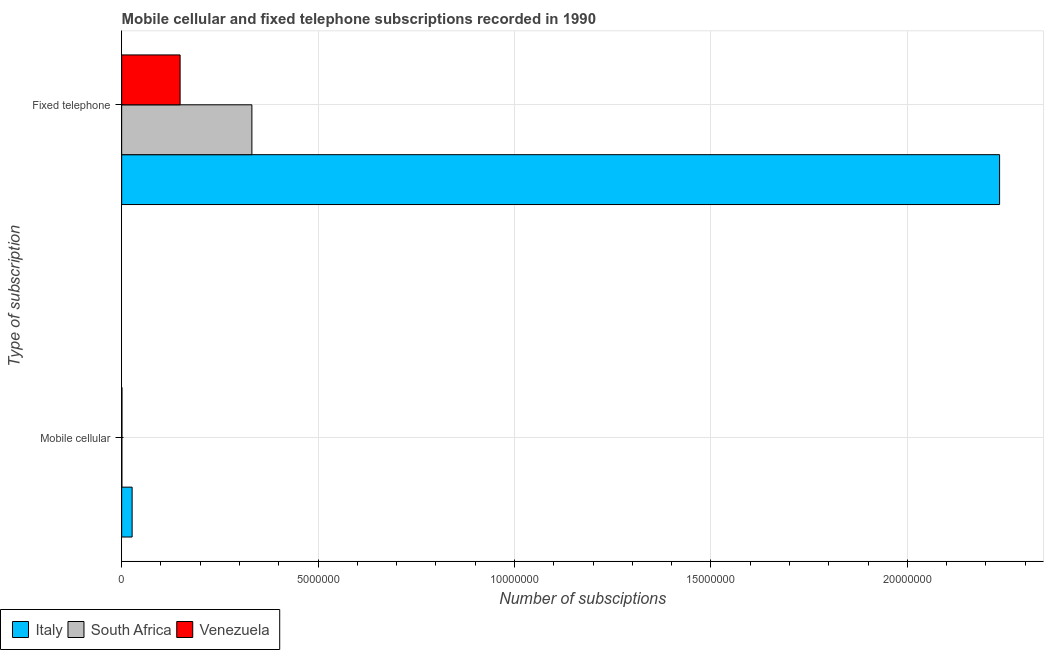How many groups of bars are there?
Your answer should be compact. 2. How many bars are there on the 2nd tick from the top?
Provide a short and direct response. 3. How many bars are there on the 1st tick from the bottom?
Your response must be concise. 3. What is the label of the 1st group of bars from the top?
Offer a terse response. Fixed telephone. What is the number of fixed telephone subscriptions in South Africa?
Provide a succinct answer. 3.32e+06. Across all countries, what is the maximum number of mobile cellular subscriptions?
Provide a short and direct response. 2.66e+05. Across all countries, what is the minimum number of fixed telephone subscriptions?
Offer a very short reply. 1.49e+06. In which country was the number of fixed telephone subscriptions maximum?
Your answer should be very brief. Italy. In which country was the number of fixed telephone subscriptions minimum?
Offer a terse response. Venezuela. What is the total number of mobile cellular subscriptions in the graph?
Offer a terse response. 2.79e+05. What is the difference between the number of fixed telephone subscriptions in South Africa and that in Venezuela?
Your answer should be compact. 1.83e+06. What is the difference between the number of fixed telephone subscriptions in Italy and the number of mobile cellular subscriptions in South Africa?
Your answer should be very brief. 2.23e+07. What is the average number of mobile cellular subscriptions per country?
Provide a succinct answer. 9.30e+04. What is the difference between the number of fixed telephone subscriptions and number of mobile cellular subscriptions in Italy?
Offer a terse response. 2.21e+07. What is the ratio of the number of fixed telephone subscriptions in Venezuela to that in South Africa?
Your answer should be compact. 0.45. Is the number of fixed telephone subscriptions in Venezuela less than that in South Africa?
Keep it short and to the point. Yes. In how many countries, is the number of mobile cellular subscriptions greater than the average number of mobile cellular subscriptions taken over all countries?
Your answer should be compact. 1. What does the 2nd bar from the top in Fixed telephone represents?
Give a very brief answer. South Africa. What does the 3rd bar from the bottom in Fixed telephone represents?
Keep it short and to the point. Venezuela. How many countries are there in the graph?
Provide a short and direct response. 3. What is the difference between two consecutive major ticks on the X-axis?
Provide a succinct answer. 5.00e+06. Does the graph contain any zero values?
Your answer should be compact. No. Does the graph contain grids?
Offer a terse response. Yes. Where does the legend appear in the graph?
Your answer should be very brief. Bottom left. How are the legend labels stacked?
Your response must be concise. Horizontal. What is the title of the graph?
Your response must be concise. Mobile cellular and fixed telephone subscriptions recorded in 1990. Does "Tajikistan" appear as one of the legend labels in the graph?
Ensure brevity in your answer.  No. What is the label or title of the X-axis?
Your response must be concise. Number of subsciptions. What is the label or title of the Y-axis?
Provide a short and direct response. Type of subscription. What is the Number of subsciptions in Italy in Mobile cellular?
Make the answer very short. 2.66e+05. What is the Number of subsciptions of South Africa in Mobile cellular?
Your answer should be compact. 5680. What is the Number of subsciptions in Venezuela in Mobile cellular?
Your response must be concise. 7422. What is the Number of subsciptions of Italy in Fixed telephone?
Your response must be concise. 2.24e+07. What is the Number of subsciptions of South Africa in Fixed telephone?
Ensure brevity in your answer.  3.32e+06. What is the Number of subsciptions of Venezuela in Fixed telephone?
Offer a terse response. 1.49e+06. Across all Type of subscription, what is the maximum Number of subsciptions of Italy?
Provide a short and direct response. 2.24e+07. Across all Type of subscription, what is the maximum Number of subsciptions of South Africa?
Provide a short and direct response. 3.32e+06. Across all Type of subscription, what is the maximum Number of subsciptions of Venezuela?
Offer a very short reply. 1.49e+06. Across all Type of subscription, what is the minimum Number of subsciptions in Italy?
Offer a very short reply. 2.66e+05. Across all Type of subscription, what is the minimum Number of subsciptions in South Africa?
Offer a terse response. 5680. Across all Type of subscription, what is the minimum Number of subsciptions in Venezuela?
Your answer should be compact. 7422. What is the total Number of subsciptions of Italy in the graph?
Keep it short and to the point. 2.26e+07. What is the total Number of subsciptions of South Africa in the graph?
Your response must be concise. 3.32e+06. What is the total Number of subsciptions in Venezuela in the graph?
Provide a short and direct response. 1.50e+06. What is the difference between the Number of subsciptions in Italy in Mobile cellular and that in Fixed telephone?
Your answer should be compact. -2.21e+07. What is the difference between the Number of subsciptions in South Africa in Mobile cellular and that in Fixed telephone?
Offer a very short reply. -3.31e+06. What is the difference between the Number of subsciptions in Venezuela in Mobile cellular and that in Fixed telephone?
Make the answer very short. -1.48e+06. What is the difference between the Number of subsciptions in Italy in Mobile cellular and the Number of subsciptions in South Africa in Fixed telephone?
Offer a very short reply. -3.05e+06. What is the difference between the Number of subsciptions in Italy in Mobile cellular and the Number of subsciptions in Venezuela in Fixed telephone?
Offer a terse response. -1.22e+06. What is the difference between the Number of subsciptions of South Africa in Mobile cellular and the Number of subsciptions of Venezuela in Fixed telephone?
Keep it short and to the point. -1.48e+06. What is the average Number of subsciptions of Italy per Type of subscription?
Offer a terse response. 1.13e+07. What is the average Number of subsciptions in South Africa per Type of subscription?
Make the answer very short. 1.66e+06. What is the average Number of subsciptions in Venezuela per Type of subscription?
Provide a short and direct response. 7.48e+05. What is the difference between the Number of subsciptions of Italy and Number of subsciptions of South Africa in Mobile cellular?
Provide a succinct answer. 2.60e+05. What is the difference between the Number of subsciptions in Italy and Number of subsciptions in Venezuela in Mobile cellular?
Your answer should be compact. 2.59e+05. What is the difference between the Number of subsciptions of South Africa and Number of subsciptions of Venezuela in Mobile cellular?
Your answer should be compact. -1742. What is the difference between the Number of subsciptions in Italy and Number of subsciptions in South Africa in Fixed telephone?
Offer a very short reply. 1.90e+07. What is the difference between the Number of subsciptions of Italy and Number of subsciptions of Venezuela in Fixed telephone?
Offer a terse response. 2.09e+07. What is the difference between the Number of subsciptions in South Africa and Number of subsciptions in Venezuela in Fixed telephone?
Keep it short and to the point. 1.83e+06. What is the ratio of the Number of subsciptions of Italy in Mobile cellular to that in Fixed telephone?
Offer a very short reply. 0.01. What is the ratio of the Number of subsciptions in South Africa in Mobile cellular to that in Fixed telephone?
Provide a short and direct response. 0. What is the ratio of the Number of subsciptions in Venezuela in Mobile cellular to that in Fixed telephone?
Provide a succinct answer. 0.01. What is the difference between the highest and the second highest Number of subsciptions of Italy?
Your answer should be very brief. 2.21e+07. What is the difference between the highest and the second highest Number of subsciptions of South Africa?
Your answer should be very brief. 3.31e+06. What is the difference between the highest and the second highest Number of subsciptions in Venezuela?
Make the answer very short. 1.48e+06. What is the difference between the highest and the lowest Number of subsciptions in Italy?
Offer a very short reply. 2.21e+07. What is the difference between the highest and the lowest Number of subsciptions in South Africa?
Your answer should be very brief. 3.31e+06. What is the difference between the highest and the lowest Number of subsciptions of Venezuela?
Give a very brief answer. 1.48e+06. 